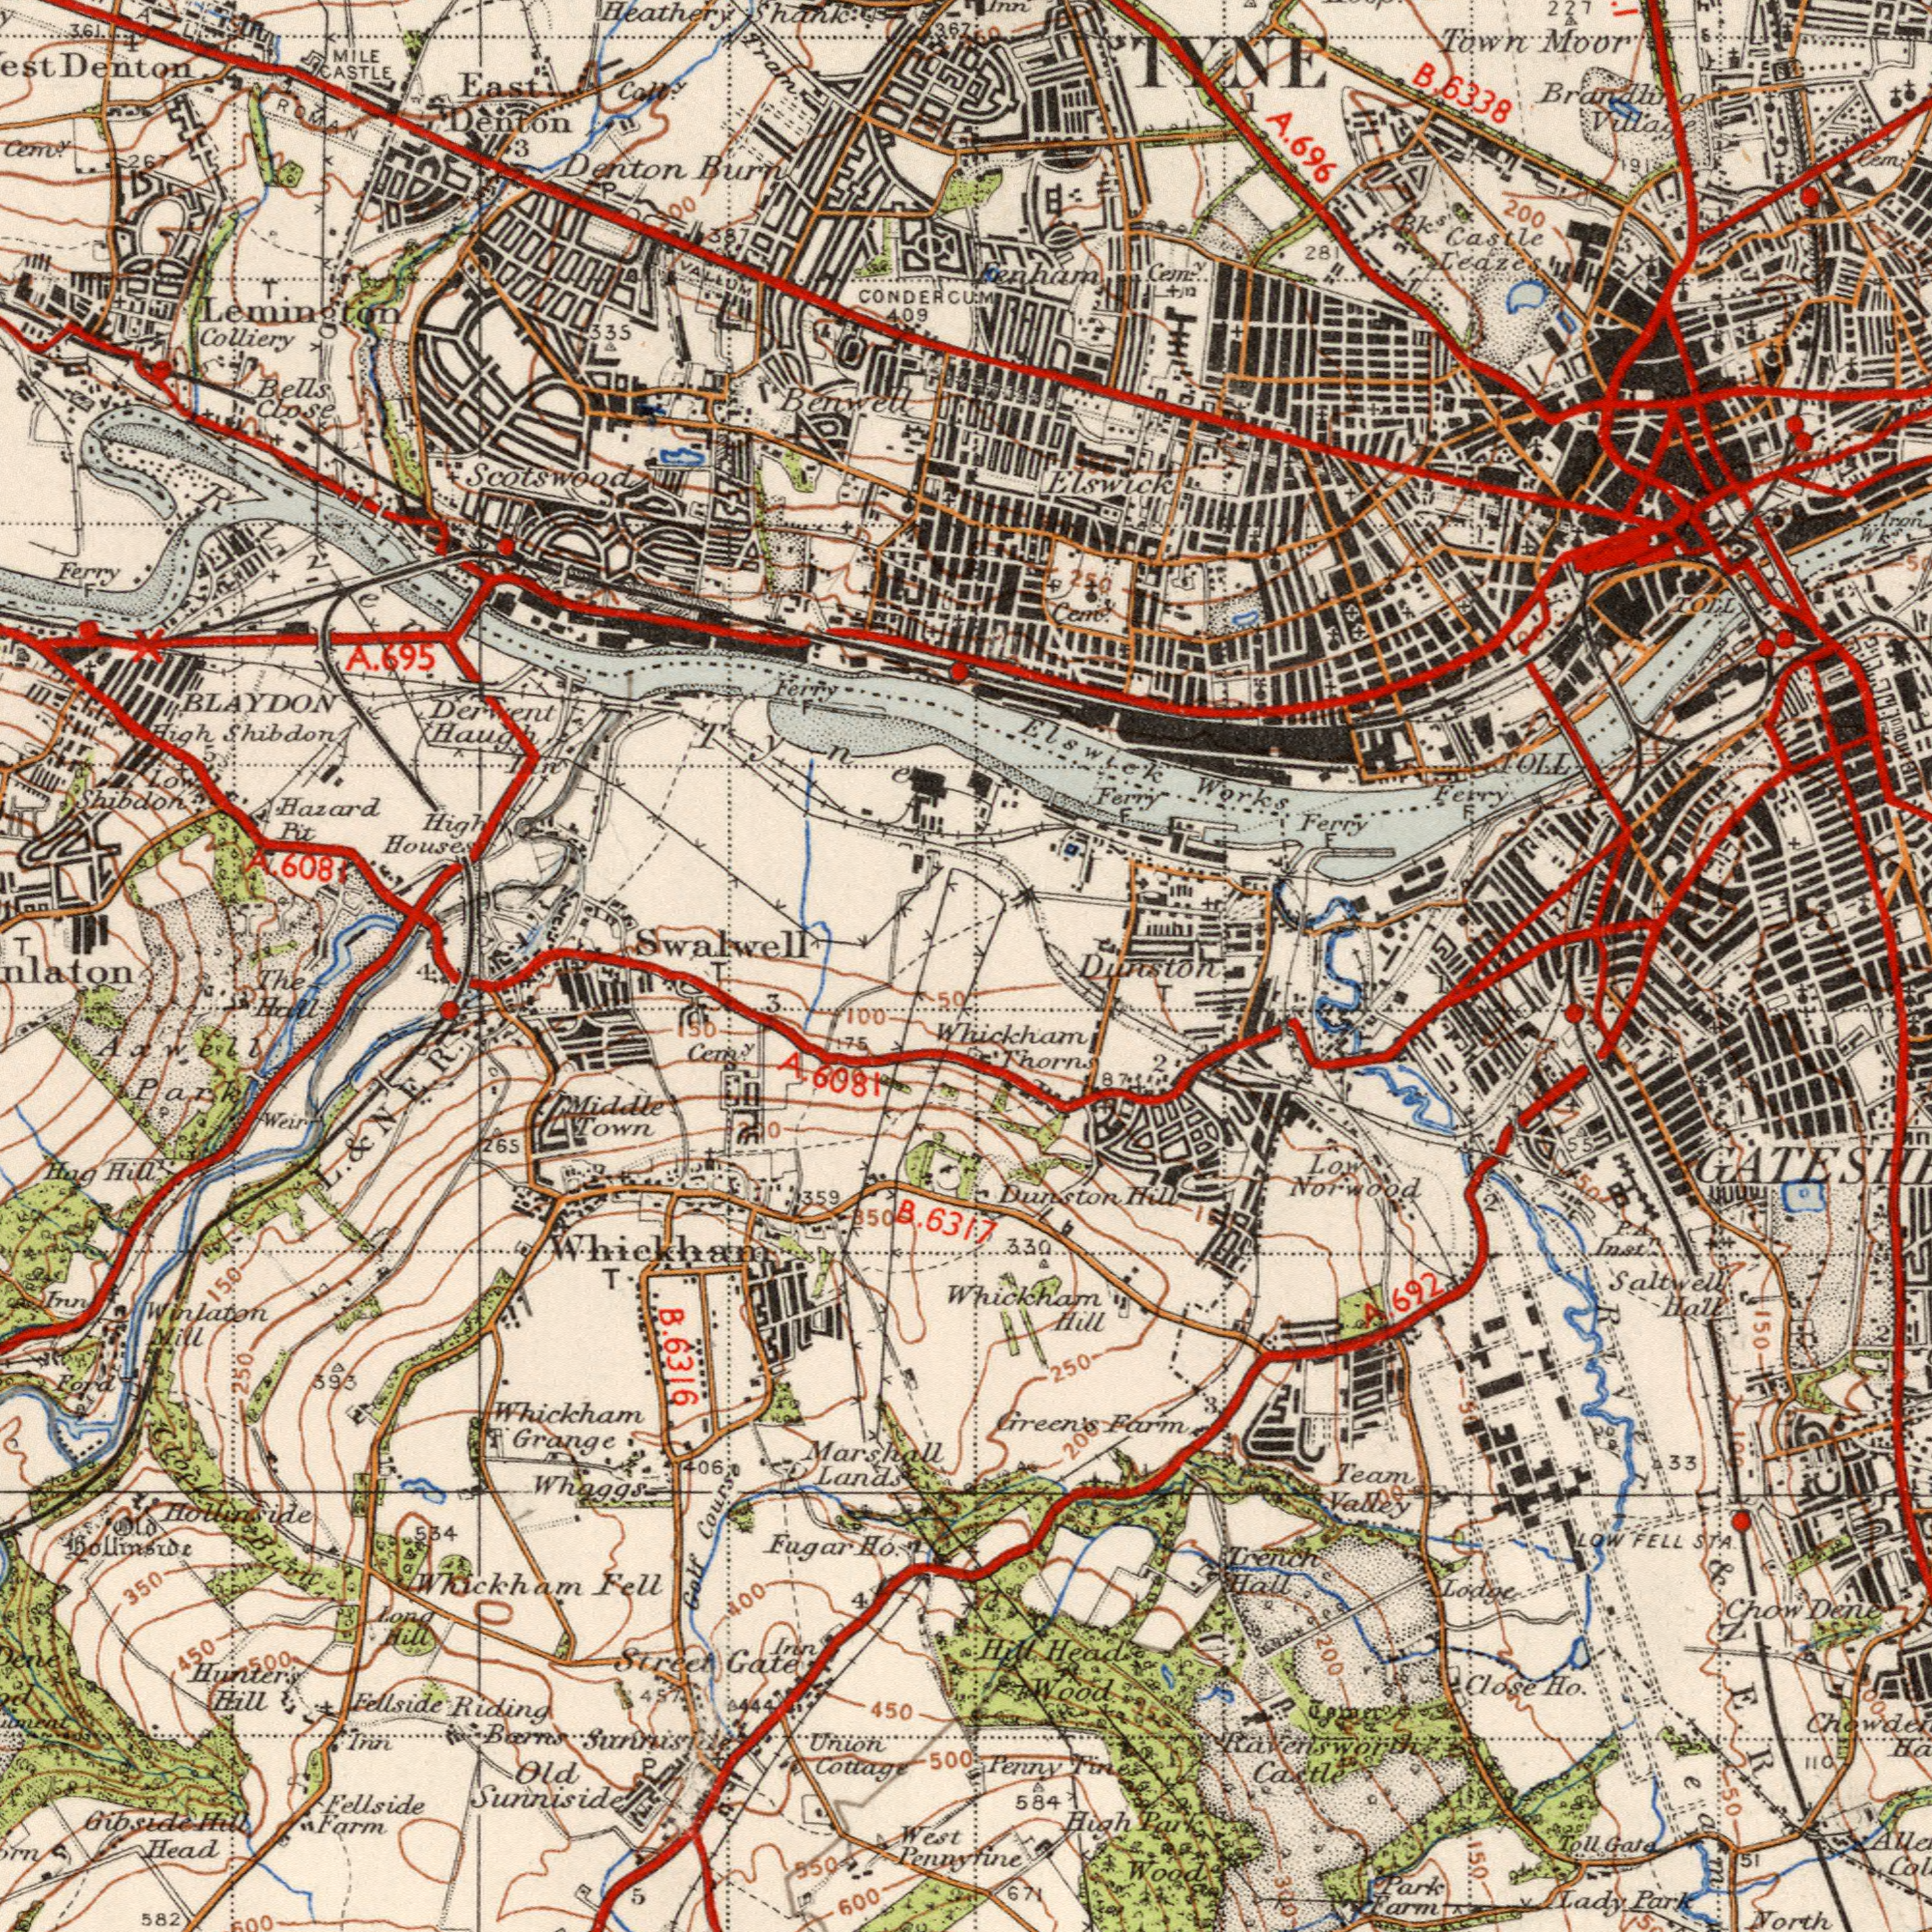What text is shown in the top-left quadrant? BLAYDON Hazard Denton Scotswood Denton House Colliery Burn High Shibdon Shank Benwell Bells Haugh Denton East CONDERCUM Cem<sup>y</sup> Lemington MILE Pit Close A. Cou<sup>y</sup> Tram Ferry CASTLE Swalwell 361 T. 335 3 409 T Shibdon 267 Heathery Low Ferry Derwent 6081 P A ###00 ROMAN High Tyne F 4 367 387 VALLUM 5 F 695 A. River Iin What text is visible in the upper-right corner? Castle Moor Town Village 200 TOLL TYNE 28 Ferry 6338 Bk<sup>s</sup> Ferry Elswick Cem<sup>y</sup> Fenham Elswick Leazes Ferry Cem<sup>y</sup> TOLL Brandling Cem<sup>y</sup> 227 Works F 696 Iron 250 Inn 191 1 Wk<sup>s</sup> F F A. B. Dunston ###0 ###60 What text is visible in the lower-left corner? Winlaton Whickham Street Whaggs Head Riding 582 West Lands Fellside Whickham Fellside Penny Bollinside Farm 3 Fugar Old 600 Course Grange Hill Hollinside Gibside 100 Gate 393 Sunniside 265 Long Marshall Hill Middle 5 Golf Hag R. Union The 450 Hill Burn Ho. Cottage Mill E. Weir 6317 Sunniside 250 6081 Hall Hunters 450 Whickham B. 150 Ford Fell 359 Inn Barns Inn 350 400 150 B. Axwell Cem<sup>y</sup> Town Inn Old 534 850 500 T 950 Hill 4 175 6316 Park 600 L. 500 406 50 N. & 4 A. T 300 P 444 457 Clock What text is shown in the bottom-right quadrant? Wood Dunston Castle Penny Norwood Lodge Close Ho. Hill Thorn Dene High Hill North STA Hall Park Head Team Hill 250 Farm Trench Wood 584 Saltwell 692 Hall Farm 200 Low Park Valley 33 51 Whickham 50 110 Inst<sup>n</sup> Lady Chow 330 Park 671 150 200 300 FELL Gata Toll Raversworth 2 Whickham LOW 55 150 Fine A. Green's 50 87 T 2 P. 2 100 100 A. 3 L. & N. Team ###00 River E. R. 